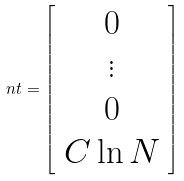<formula> <loc_0><loc_0><loc_500><loc_500>\ n t = \left [ \begin{array} { c } 0 \\ \vdots \\ 0 \\ C \ln N \end{array} \right ]</formula> 